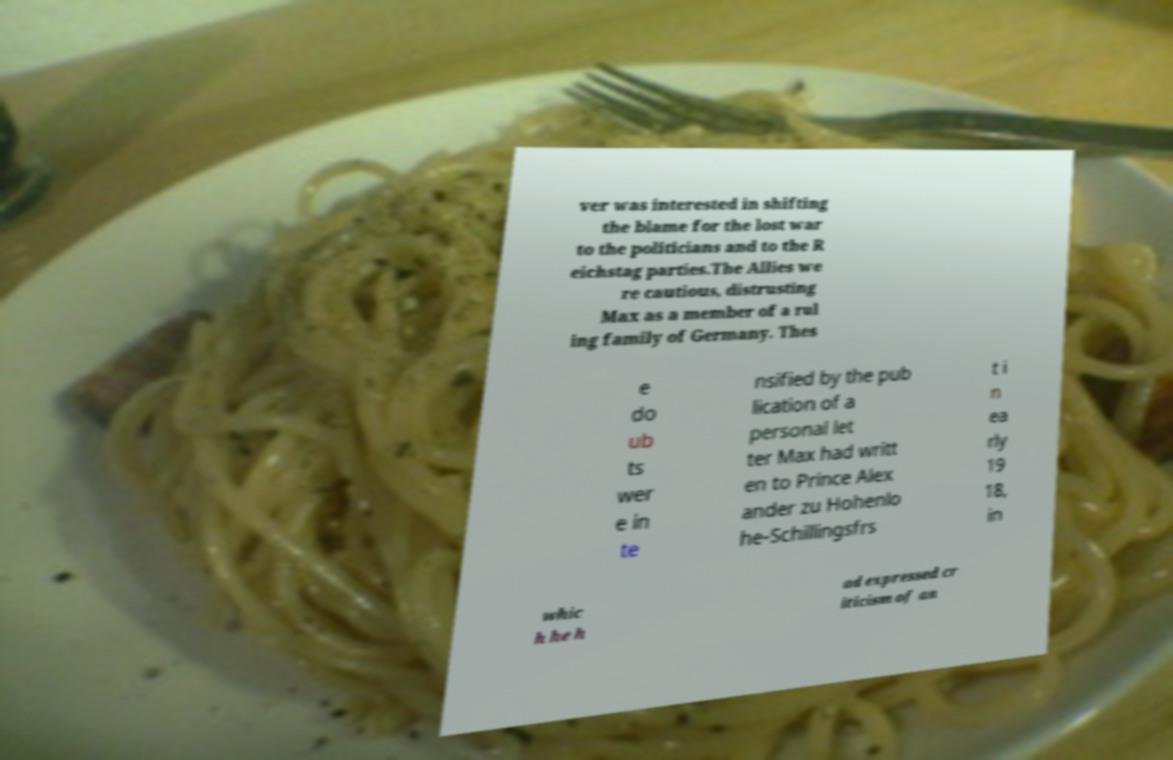Please identify and transcribe the text found in this image. ver was interested in shifting the blame for the lost war to the politicians and to the R eichstag parties.The Allies we re cautious, distrusting Max as a member of a rul ing family of Germany. Thes e do ub ts wer e in te nsified by the pub lication of a personal let ter Max had writt en to Prince Alex ander zu Hohenlo he-Schillingsfrs t i n ea rly 19 18, in whic h he h ad expressed cr iticism of an 